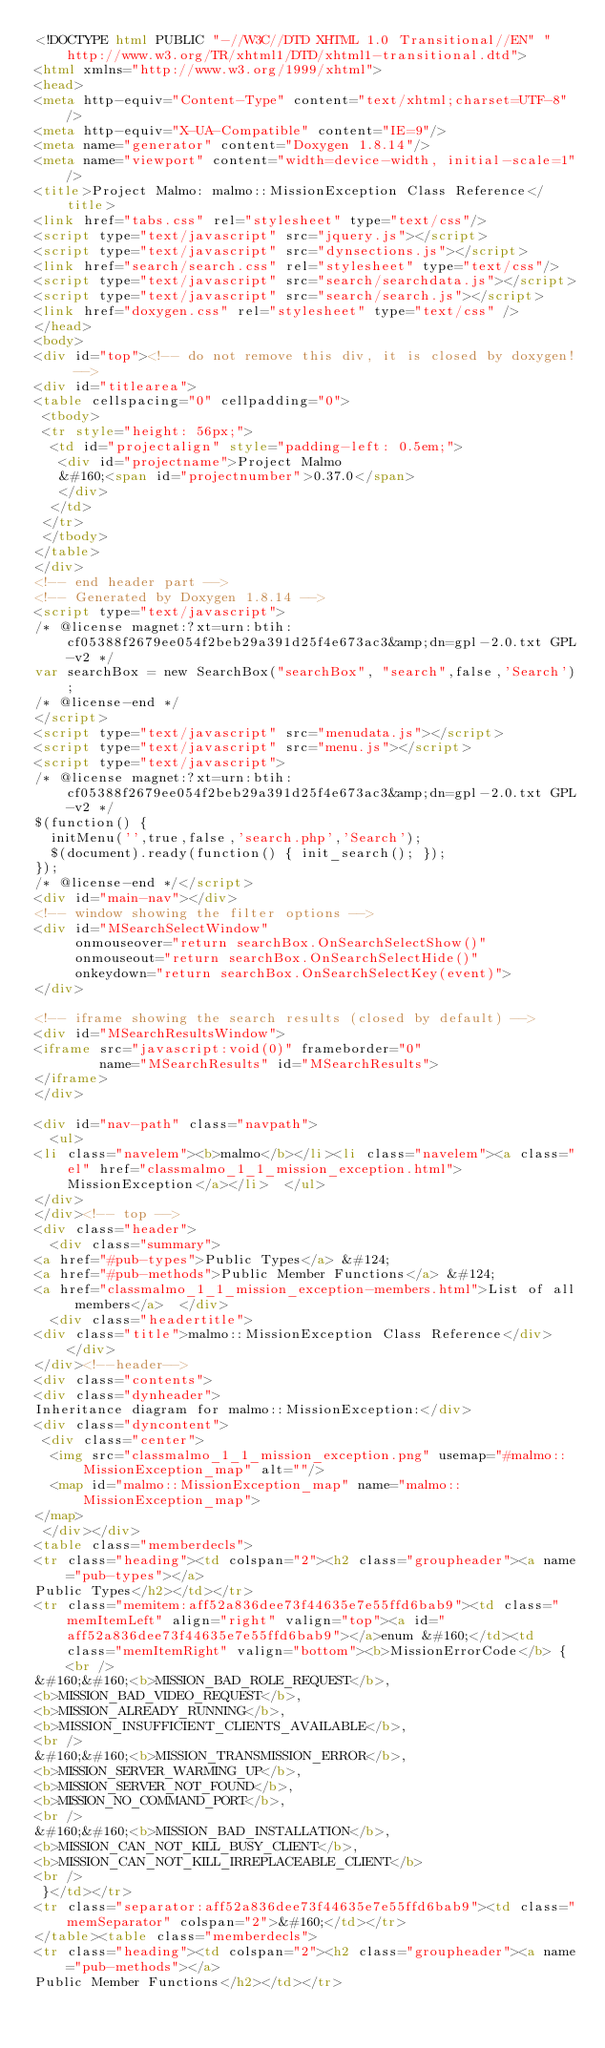<code> <loc_0><loc_0><loc_500><loc_500><_HTML_><!DOCTYPE html PUBLIC "-//W3C//DTD XHTML 1.0 Transitional//EN" "http://www.w3.org/TR/xhtml1/DTD/xhtml1-transitional.dtd">
<html xmlns="http://www.w3.org/1999/xhtml">
<head>
<meta http-equiv="Content-Type" content="text/xhtml;charset=UTF-8"/>
<meta http-equiv="X-UA-Compatible" content="IE=9"/>
<meta name="generator" content="Doxygen 1.8.14"/>
<meta name="viewport" content="width=device-width, initial-scale=1"/>
<title>Project Malmo: malmo::MissionException Class Reference</title>
<link href="tabs.css" rel="stylesheet" type="text/css"/>
<script type="text/javascript" src="jquery.js"></script>
<script type="text/javascript" src="dynsections.js"></script>
<link href="search/search.css" rel="stylesheet" type="text/css"/>
<script type="text/javascript" src="search/searchdata.js"></script>
<script type="text/javascript" src="search/search.js"></script>
<link href="doxygen.css" rel="stylesheet" type="text/css" />
</head>
<body>
<div id="top"><!-- do not remove this div, it is closed by doxygen! -->
<div id="titlearea">
<table cellspacing="0" cellpadding="0">
 <tbody>
 <tr style="height: 56px;">
  <td id="projectalign" style="padding-left: 0.5em;">
   <div id="projectname">Project Malmo
   &#160;<span id="projectnumber">0.37.0</span>
   </div>
  </td>
 </tr>
 </tbody>
</table>
</div>
<!-- end header part -->
<!-- Generated by Doxygen 1.8.14 -->
<script type="text/javascript">
/* @license magnet:?xt=urn:btih:cf05388f2679ee054f2beb29a391d25f4e673ac3&amp;dn=gpl-2.0.txt GPL-v2 */
var searchBox = new SearchBox("searchBox", "search",false,'Search');
/* @license-end */
</script>
<script type="text/javascript" src="menudata.js"></script>
<script type="text/javascript" src="menu.js"></script>
<script type="text/javascript">
/* @license magnet:?xt=urn:btih:cf05388f2679ee054f2beb29a391d25f4e673ac3&amp;dn=gpl-2.0.txt GPL-v2 */
$(function() {
  initMenu('',true,false,'search.php','Search');
  $(document).ready(function() { init_search(); });
});
/* @license-end */</script>
<div id="main-nav"></div>
<!-- window showing the filter options -->
<div id="MSearchSelectWindow"
     onmouseover="return searchBox.OnSearchSelectShow()"
     onmouseout="return searchBox.OnSearchSelectHide()"
     onkeydown="return searchBox.OnSearchSelectKey(event)">
</div>

<!-- iframe showing the search results (closed by default) -->
<div id="MSearchResultsWindow">
<iframe src="javascript:void(0)" frameborder="0" 
        name="MSearchResults" id="MSearchResults">
</iframe>
</div>

<div id="nav-path" class="navpath">
  <ul>
<li class="navelem"><b>malmo</b></li><li class="navelem"><a class="el" href="classmalmo_1_1_mission_exception.html">MissionException</a></li>  </ul>
</div>
</div><!-- top -->
<div class="header">
  <div class="summary">
<a href="#pub-types">Public Types</a> &#124;
<a href="#pub-methods">Public Member Functions</a> &#124;
<a href="classmalmo_1_1_mission_exception-members.html">List of all members</a>  </div>
  <div class="headertitle">
<div class="title">malmo::MissionException Class Reference</div>  </div>
</div><!--header-->
<div class="contents">
<div class="dynheader">
Inheritance diagram for malmo::MissionException:</div>
<div class="dyncontent">
 <div class="center">
  <img src="classmalmo_1_1_mission_exception.png" usemap="#malmo::MissionException_map" alt=""/>
  <map id="malmo::MissionException_map" name="malmo::MissionException_map">
</map>
 </div></div>
<table class="memberdecls">
<tr class="heading"><td colspan="2"><h2 class="groupheader"><a name="pub-types"></a>
Public Types</h2></td></tr>
<tr class="memitem:aff52a836dee73f44635e7e55ffd6bab9"><td class="memItemLeft" align="right" valign="top"><a id="aff52a836dee73f44635e7e55ffd6bab9"></a>enum &#160;</td><td class="memItemRight" valign="bottom"><b>MissionErrorCode</b> { <br />
&#160;&#160;<b>MISSION_BAD_ROLE_REQUEST</b>, 
<b>MISSION_BAD_VIDEO_REQUEST</b>, 
<b>MISSION_ALREADY_RUNNING</b>, 
<b>MISSION_INSUFFICIENT_CLIENTS_AVAILABLE</b>, 
<br />
&#160;&#160;<b>MISSION_TRANSMISSION_ERROR</b>, 
<b>MISSION_SERVER_WARMING_UP</b>, 
<b>MISSION_SERVER_NOT_FOUND</b>, 
<b>MISSION_NO_COMMAND_PORT</b>, 
<br />
&#160;&#160;<b>MISSION_BAD_INSTALLATION</b>, 
<b>MISSION_CAN_NOT_KILL_BUSY_CLIENT</b>, 
<b>MISSION_CAN_NOT_KILL_IRREPLACEABLE_CLIENT</b>
<br />
 }</td></tr>
<tr class="separator:aff52a836dee73f44635e7e55ffd6bab9"><td class="memSeparator" colspan="2">&#160;</td></tr>
</table><table class="memberdecls">
<tr class="heading"><td colspan="2"><h2 class="groupheader"><a name="pub-methods"></a>
Public Member Functions</h2></td></tr></code> 